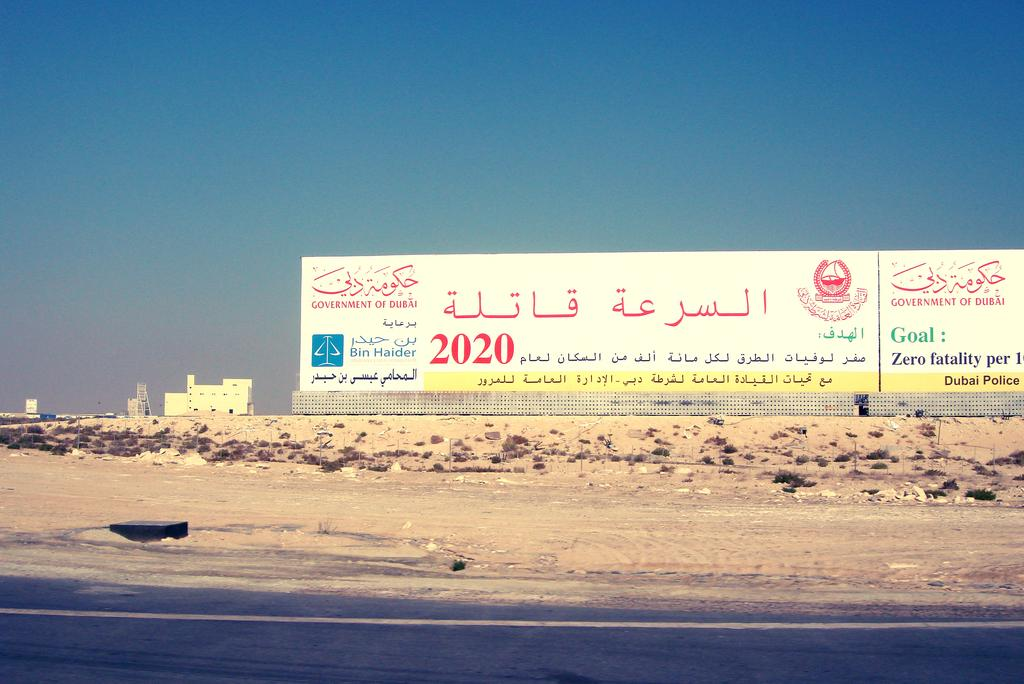<image>
Present a compact description of the photo's key features. A billboard along a sandy highway in Dubai has a message from the Dubai Police that reads Zero Fatality 